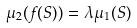<formula> <loc_0><loc_0><loc_500><loc_500>\mu _ { 2 } ( f ( S ) ) = \lambda \mu _ { 1 } ( S )</formula> 